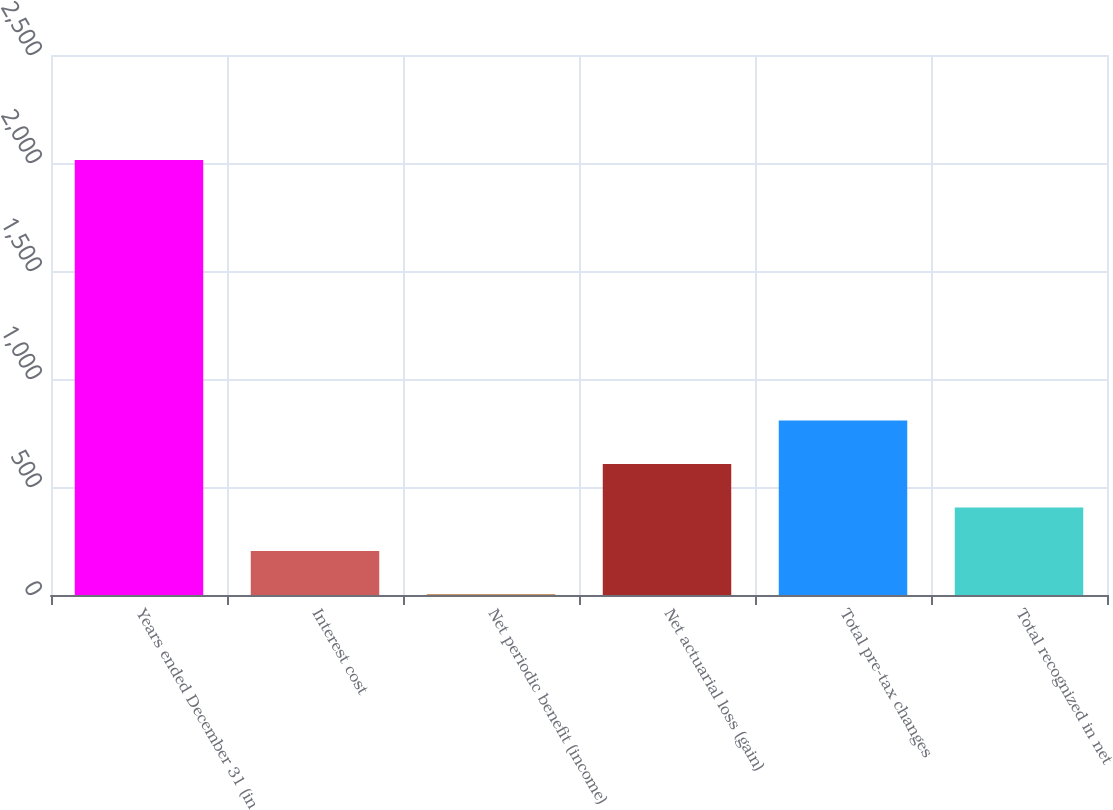<chart> <loc_0><loc_0><loc_500><loc_500><bar_chart><fcel>Years ended December 31 (in<fcel>Interest cost<fcel>Net periodic benefit (income)<fcel>Net actuarial loss (gain)<fcel>Total pre-tax changes<fcel>Total recognized in net<nl><fcel>2014<fcel>204.1<fcel>3<fcel>606.3<fcel>807.4<fcel>405.2<nl></chart> 